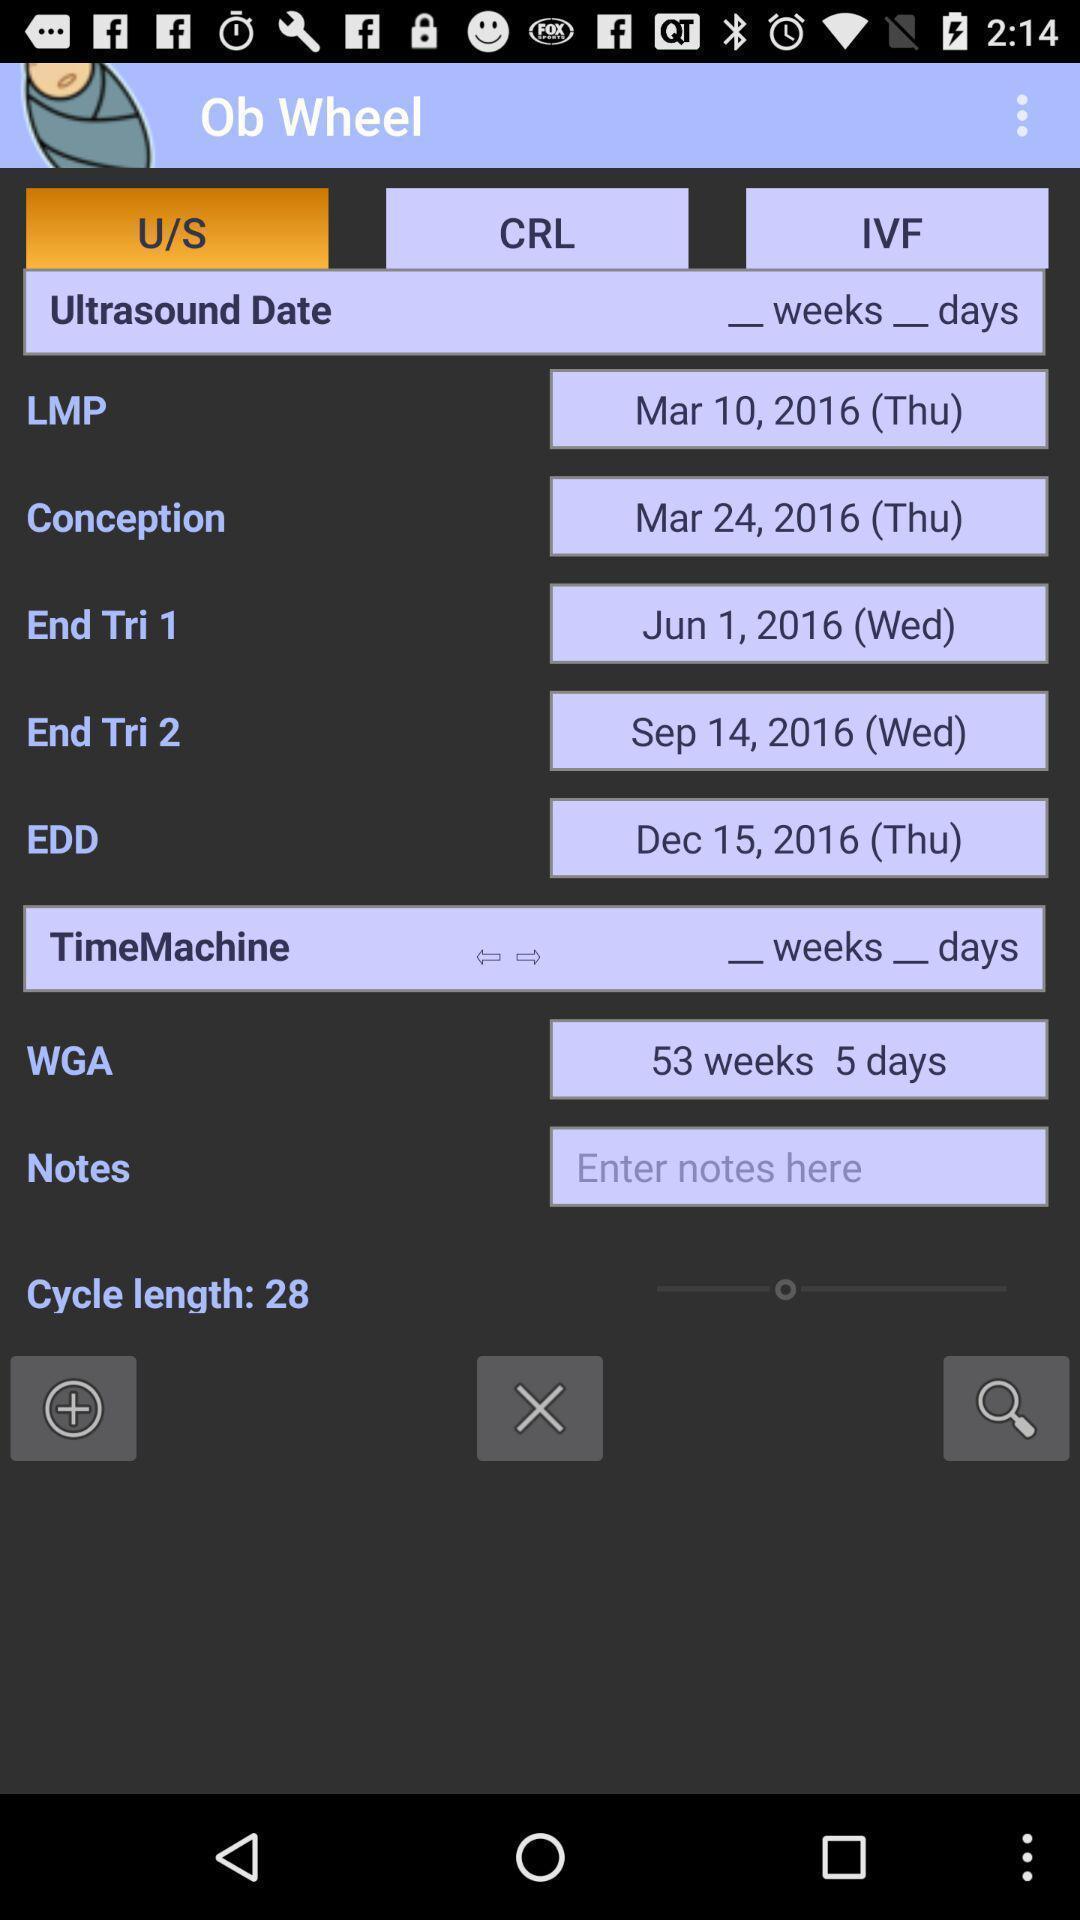Summarize the information in this screenshot. Screen shows multiple options in a health application. 